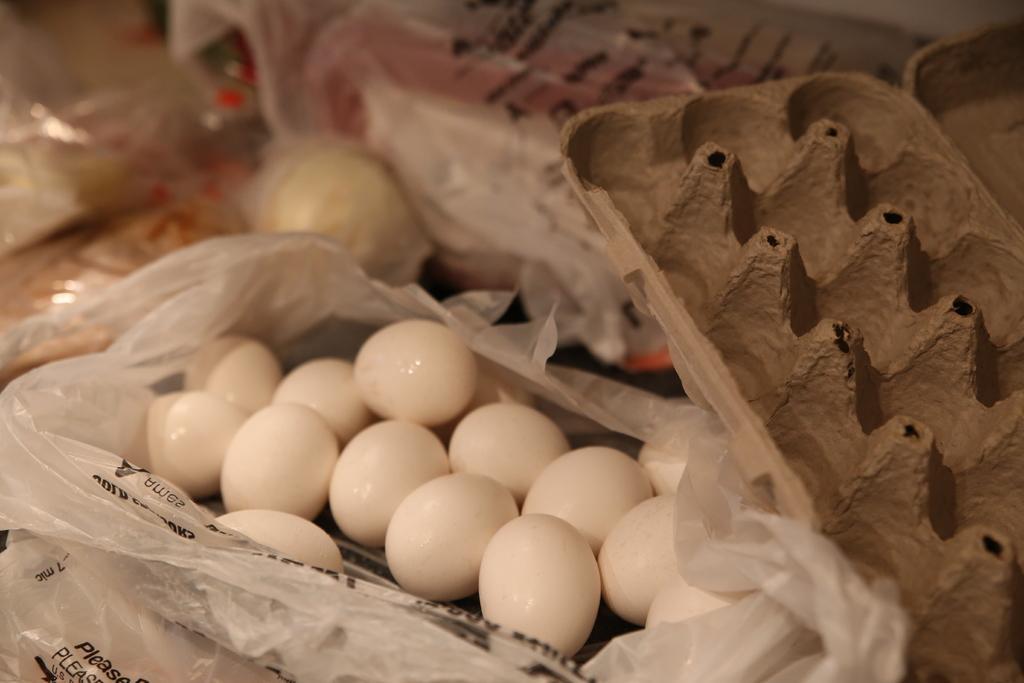Describe this image in one or two sentences. In this image there are some eggs and egg trays, and there are some plastic covers. And in the background there are some objects, and plastic covers. 